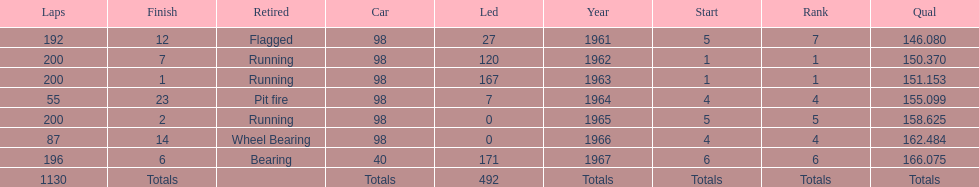What was his highest position before his first triumph? 7. 